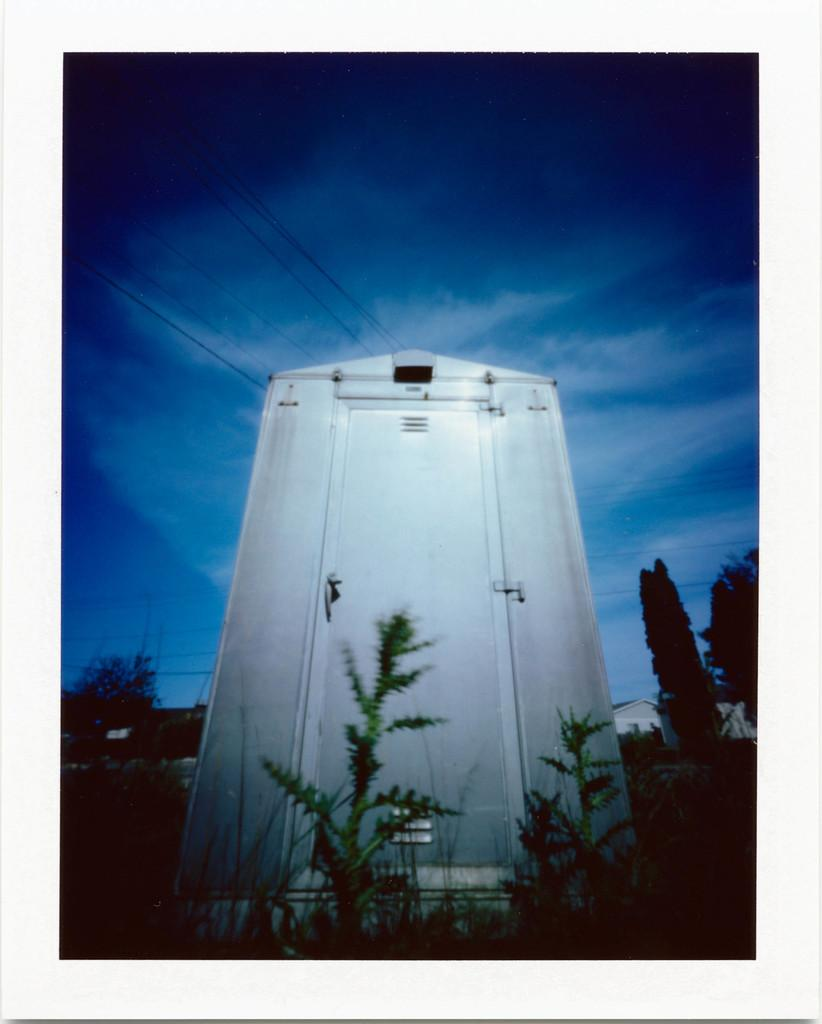What type of structure is visible in the image? There is a building in the image. What can be seen in front of the building? Trees are present in front of the building. What is visible above the building? The sky is visible above the building. What can be observed in the sky? Clouds are present in the sky. What type of hobbies are the clouds participating in within the image? The clouds are not participating in any hobbies within the image; they are simply present in the sky. 